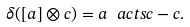Convert formula to latex. <formula><loc_0><loc_0><loc_500><loc_500>\delta ( [ a ] \otimes c ) = a \ a c t s c - c .</formula> 